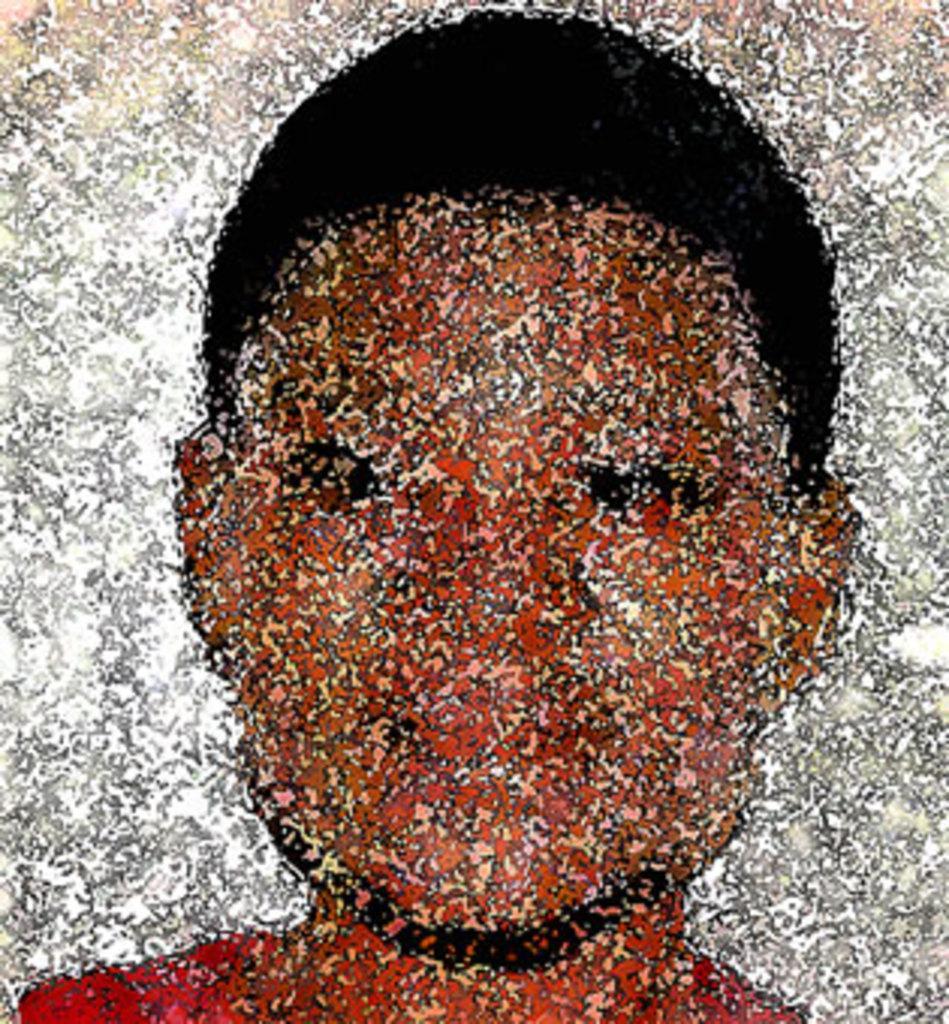Could you give a brief overview of what you see in this image? In this image we can see a photograph of a person, and the borders are white in color. 